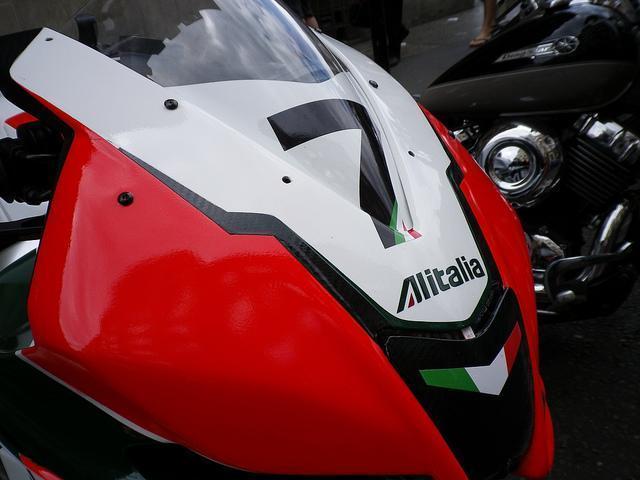How many motorcycles are there?
Give a very brief answer. 2. 